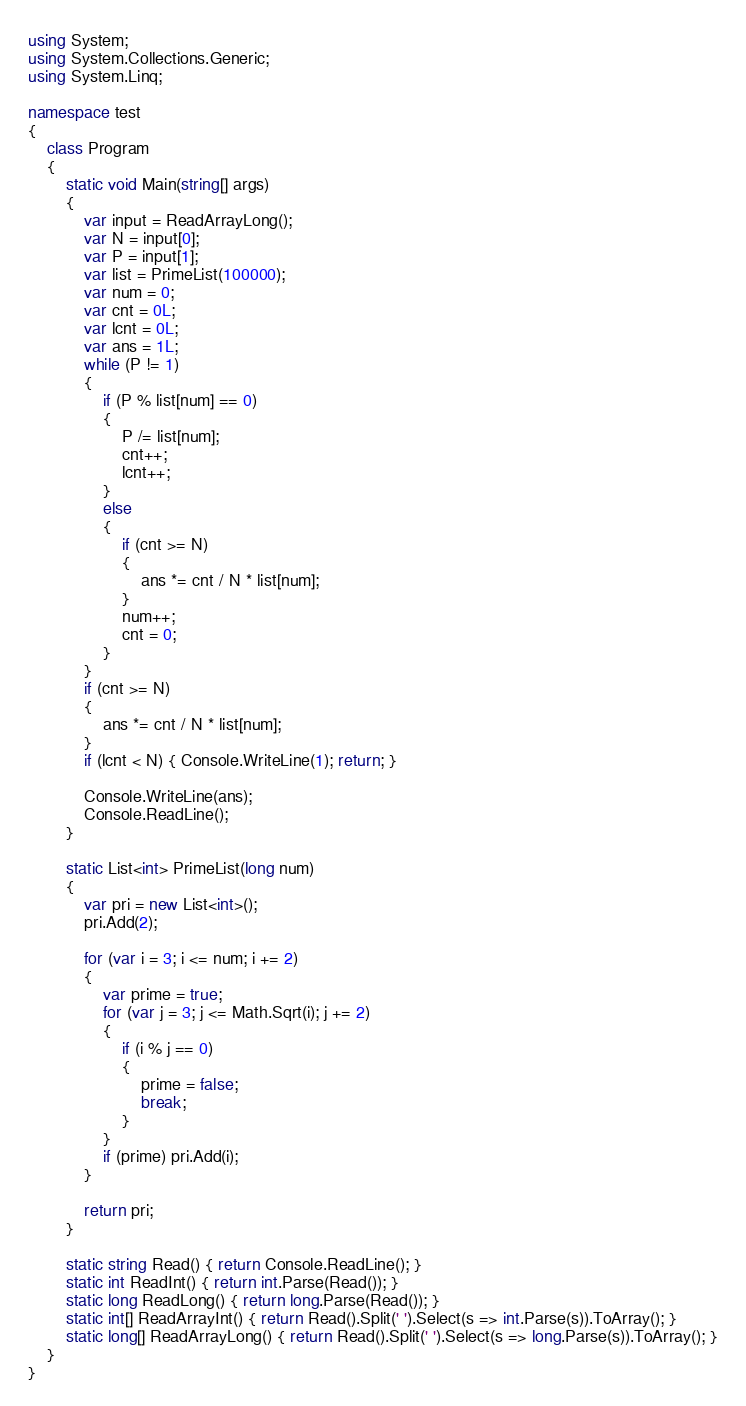<code> <loc_0><loc_0><loc_500><loc_500><_C#_>using System;
using System.Collections.Generic;
using System.Linq;

namespace test
{
    class Program
    {
        static void Main(string[] args)
        {
            var input = ReadArrayLong();
            var N = input[0];
            var P = input[1];
            var list = PrimeList(100000);
            var num = 0;
            var cnt = 0L;
            var lcnt = 0L;
            var ans = 1L;
            while (P != 1)
            {
                if (P % list[num] == 0)
                {
                    P /= list[num];
                    cnt++;
                    lcnt++;
                }
                else
                {
                    if (cnt >= N)
                    {
                        ans *= cnt / N * list[num];
                    }
                    num++;
                    cnt = 0;
                }
            }
            if (cnt >= N)
            {
                ans *= cnt / N * list[num];
            }
            if (lcnt < N) { Console.WriteLine(1); return; }

            Console.WriteLine(ans);
            Console.ReadLine();
        }

        static List<int> PrimeList(long num)
        {
            var pri = new List<int>();
            pri.Add(2);

            for (var i = 3; i <= num; i += 2)
            {
                var prime = true;
                for (var j = 3; j <= Math.Sqrt(i); j += 2)
                {
                    if (i % j == 0)
                    {
                        prime = false;
                        break;
                    }
                }
                if (prime) pri.Add(i);
            }

            return pri;
        }

        static string Read() { return Console.ReadLine(); }
        static int ReadInt() { return int.Parse(Read()); }
        static long ReadLong() { return long.Parse(Read()); }
        static int[] ReadArrayInt() { return Read().Split(' ').Select(s => int.Parse(s)).ToArray(); }
        static long[] ReadArrayLong() { return Read().Split(' ').Select(s => long.Parse(s)).ToArray(); }
    }
}</code> 